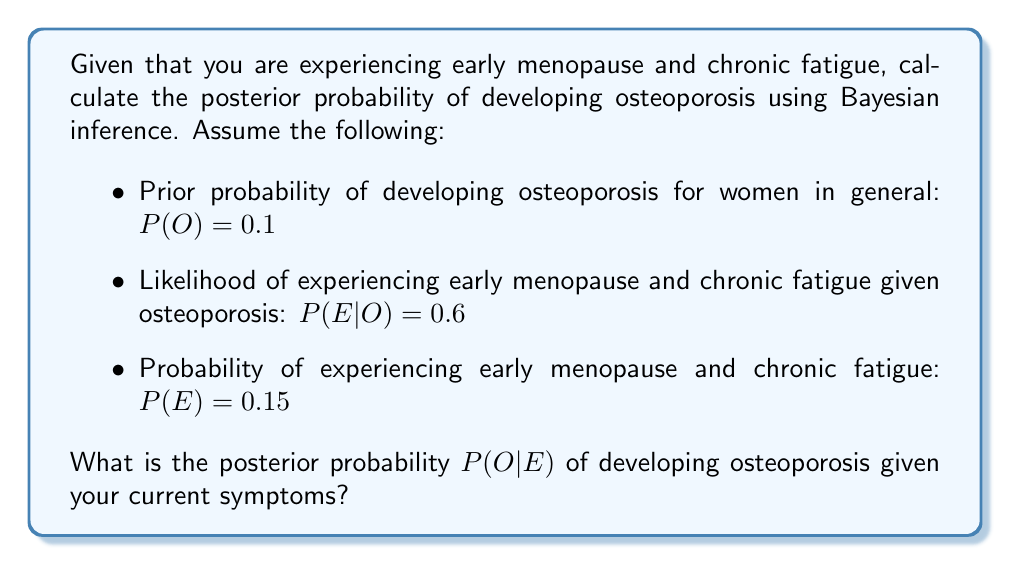Could you help me with this problem? To solve this problem, we'll use Bayes' theorem:

$$P(O|E) = \frac{P(E|O) \cdot P(O)}{P(E)}$$

Where:
$P(O|E)$ is the posterior probability of developing osteoporosis given the symptoms
$P(E|O)$ is the likelihood of experiencing the symptoms given osteoporosis
$P(O)$ is the prior probability of developing osteoporosis
$P(E)$ is the probability of experiencing the symptoms

Step 1: Substitute the given values into Bayes' theorem:

$$P(O|E) = \frac{0.6 \cdot 0.1}{0.15}$$

Step 2: Perform the calculation:

$$P(O|E) = \frac{0.06}{0.15} = 0.4$$

Therefore, the posterior probability of developing osteoporosis given the current symptoms is 0.4 or 40%.
Answer: 0.4 